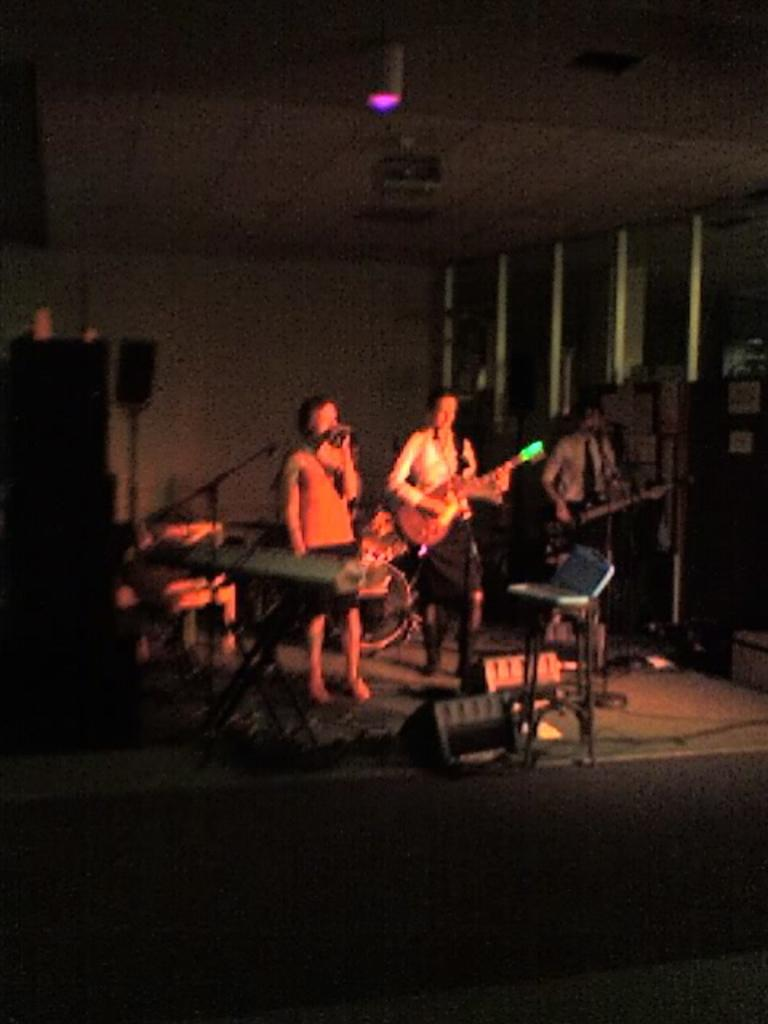What are the persons in the image doing? The group of persons in the image are playing musical instruments. What objects are associated with the musical instruments in the image? There are sound boxes and microphones in the image. Can you describe the equipment at the top of the image? There is a projector and a microphone at the top of the image. Reasoning: Let's think step by step by step in order to produce the conversation. We start by identifying the main activity of the persons in the image, which is playing musical instruments. Then, we describe the objects associated with the instruments, such as sound boxes and microphones. Finally, we mention the equipment at the top of the image, which includes a projector and a microphone. Each question is designed to elicit a specific detail about the image that is known from the provided facts. Absurd Question/Answer: What is the tendency of the word to shake in the image? There is no word present in the image, and therefore no tendency for it to shake can be observed. 